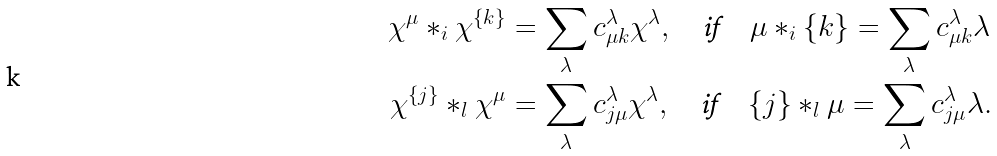Convert formula to latex. <formula><loc_0><loc_0><loc_500><loc_500>\chi ^ { \mu } \ast _ { i } \chi ^ { \{ k \} } & = \sum _ { \lambda } c _ { \mu k } ^ { \lambda } \chi ^ { \lambda } , \quad \text {if} \quad \mu \ast _ { i } \{ k \} = \sum _ { \lambda } c _ { \mu k } ^ { \lambda } \lambda \\ \chi ^ { \{ j \} } \ast _ { l } \chi ^ { \mu } & = \sum _ { \lambda } c _ { j \mu } ^ { \lambda } \chi ^ { \lambda } , \quad \text {if} \quad { \{ j \} } \ast _ { l } \mu = \sum _ { \lambda } c _ { j \mu } ^ { \lambda } \lambda .</formula> 